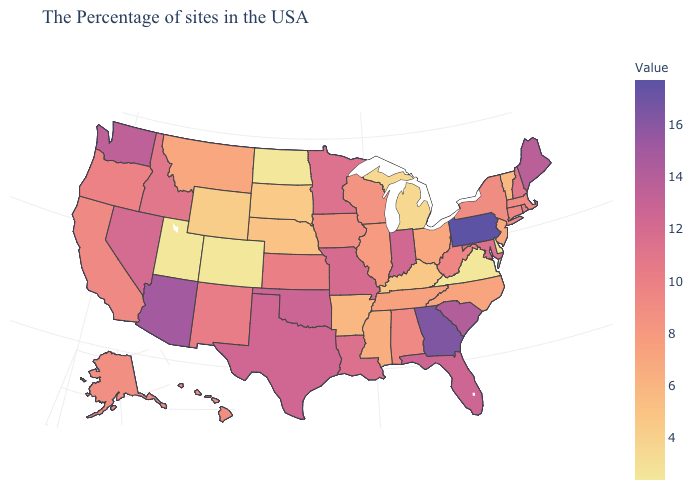Which states have the lowest value in the MidWest?
Short answer required. North Dakota. Does Colorado have the lowest value in the USA?
Keep it brief. Yes. Which states have the lowest value in the South?
Be succinct. Virginia. Which states hav the highest value in the South?
Concise answer only. Georgia. Which states have the highest value in the USA?
Answer briefly. Pennsylvania. Among the states that border Indiana , does Illinois have the highest value?
Answer briefly. Yes. 